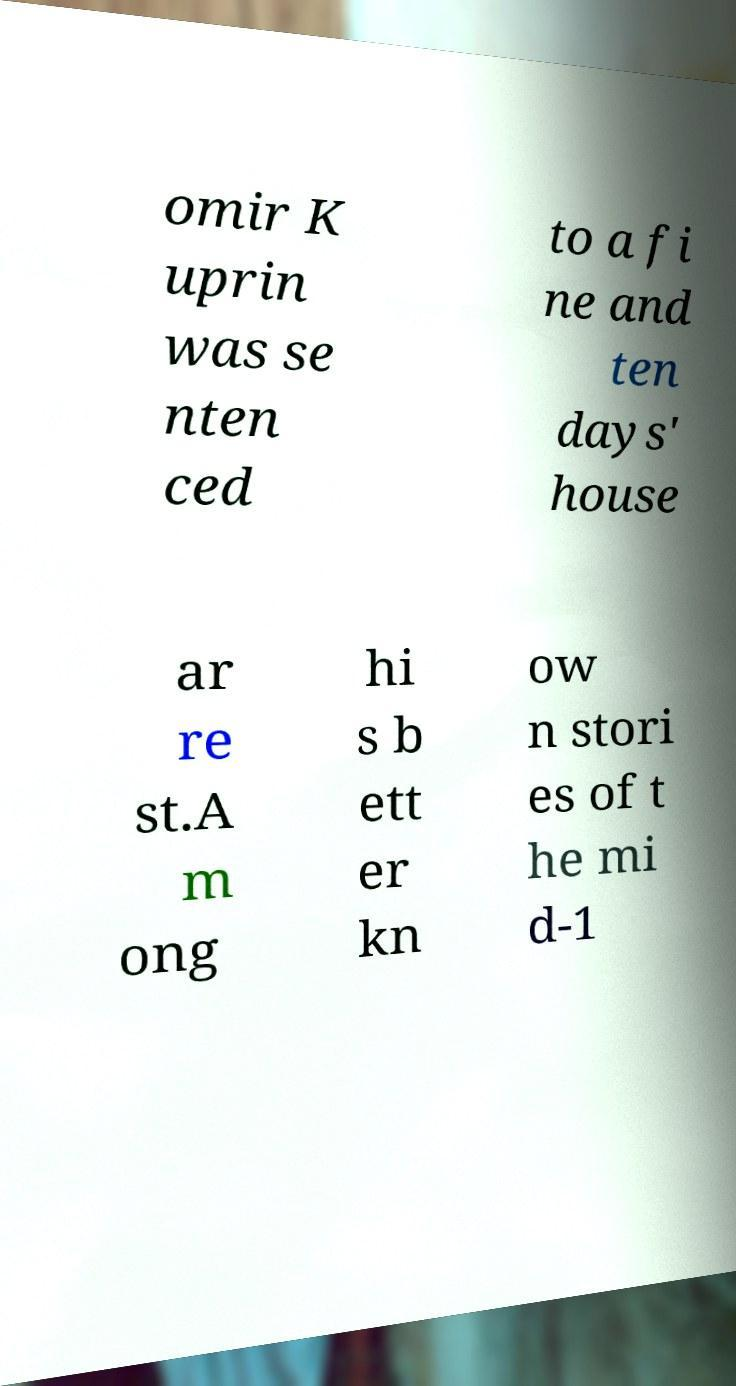Please read and relay the text visible in this image. What does it say? omir K uprin was se nten ced to a fi ne and ten days' house ar re st.A m ong hi s b ett er kn ow n stori es of t he mi d-1 